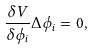Convert formula to latex. <formula><loc_0><loc_0><loc_500><loc_500>\frac { \delta V } { \delta \phi _ { i } } \Delta \phi _ { i } = 0 ,</formula> 